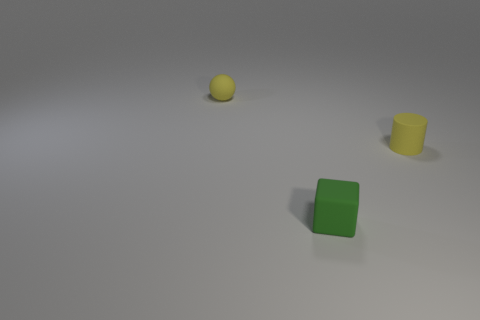Add 2 tiny yellow matte balls. How many objects exist? 5 Subtract all blocks. How many objects are left? 2 Add 3 matte cubes. How many matte cubes are left? 4 Add 1 green metallic cylinders. How many green metallic cylinders exist? 1 Subtract 0 green cylinders. How many objects are left? 3 Subtract all small red matte spheres. Subtract all tiny yellow rubber spheres. How many objects are left? 2 